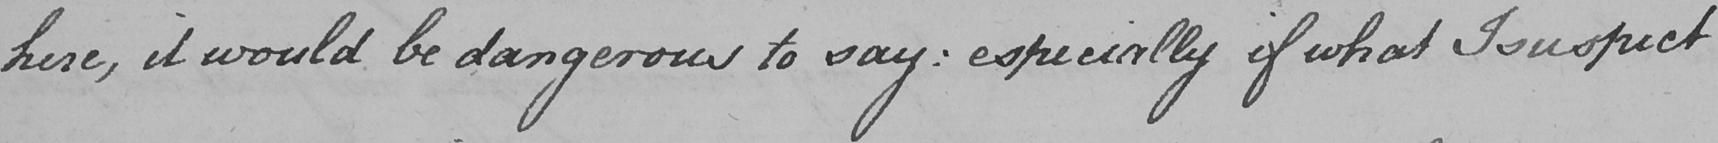Can you tell me what this handwritten text says? here , it would be dangerous to say :  especially if what I suspect 